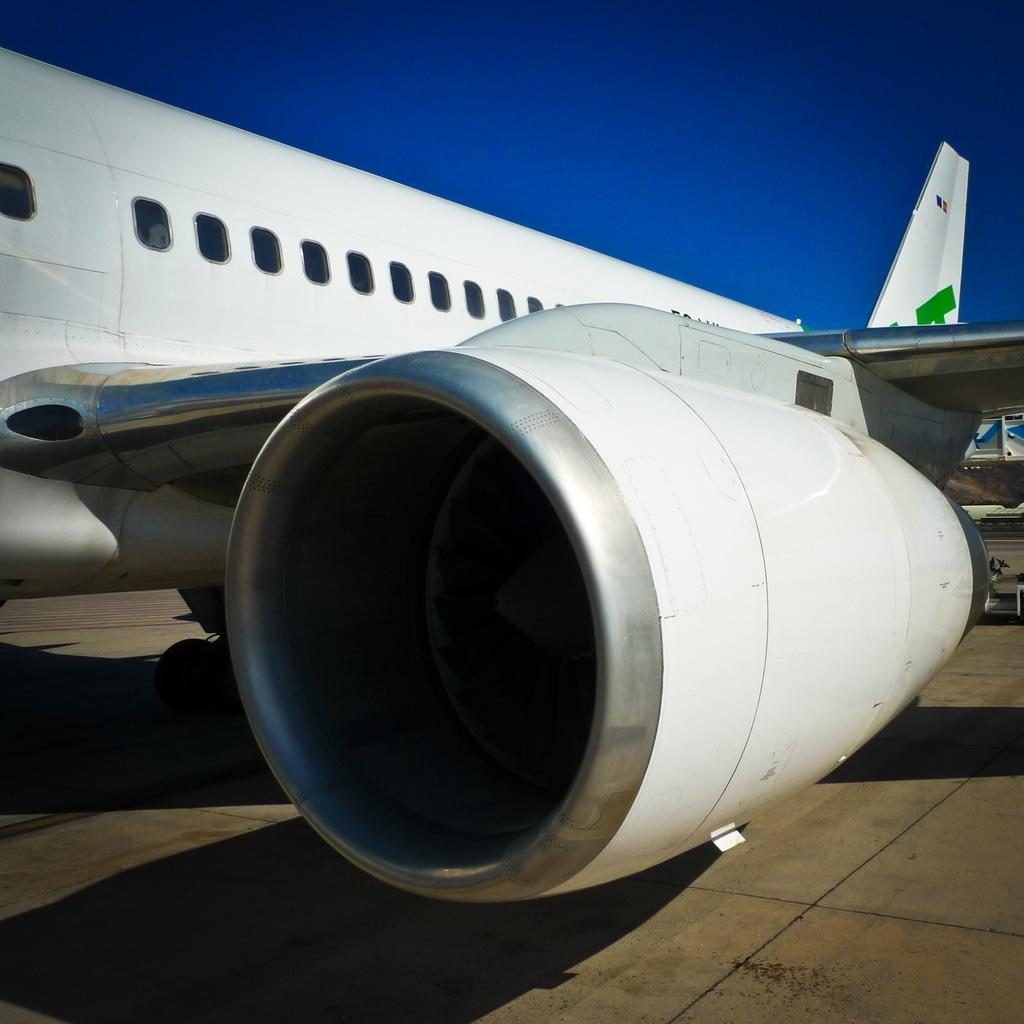What is the main object in the image? There is a propeller of an airplane in the image. What can be seen above the propeller in the image? The sky is visible at the top of the image. What can be seen below the propeller in the image? The floor is visible at the bottom of the image. What type of sand can be seen in the image? There is no sand present in the image. What is the title of the image? The provided facts do not mention a title for the image. 